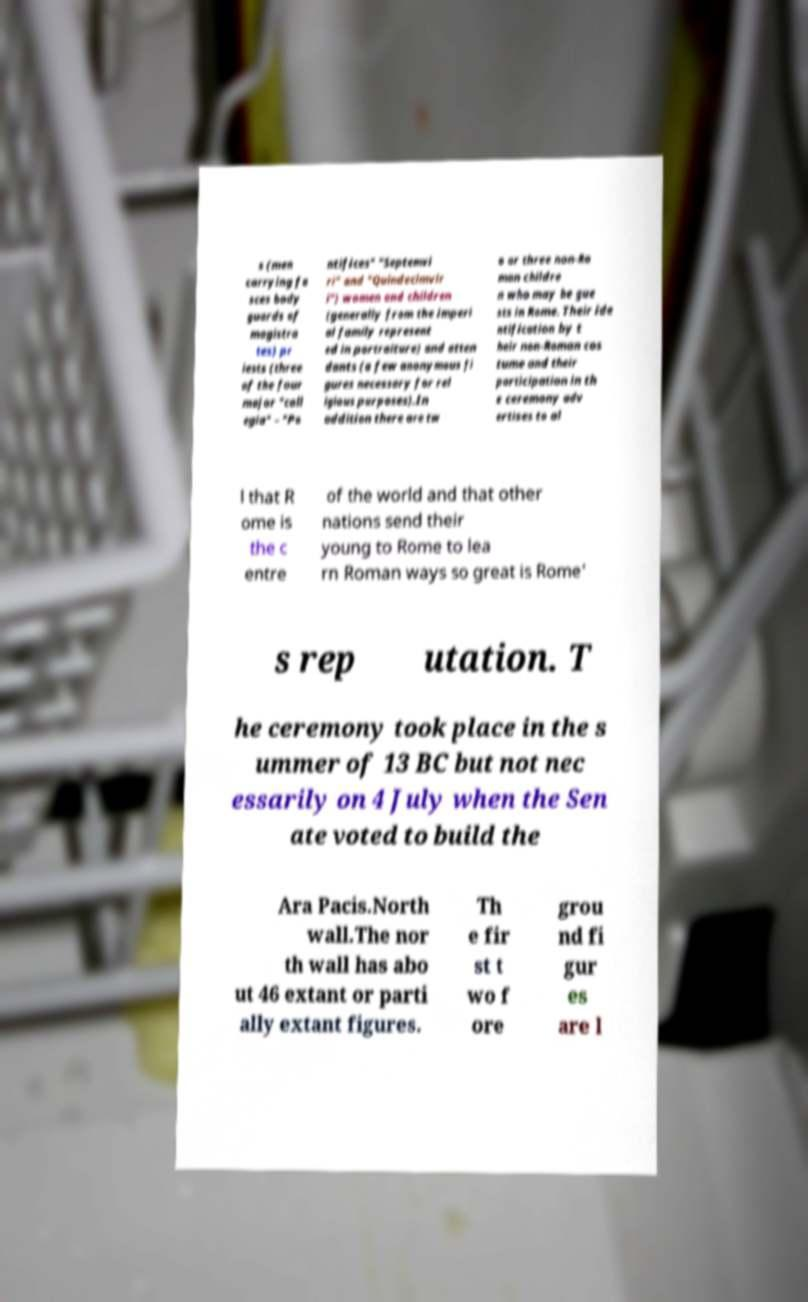Please identify and transcribe the text found in this image. s (men carrying fa sces body guards of magistra tes) pr iests (three of the four major "coll egia" – "Po ntifices" "Septemvi ri" and "Quindecimvir i") women and children (generally from the imperi al family represent ed in portraiture) and atten dants (a few anonymous fi gures necessary for rel igious purposes).In addition there are tw o or three non-Ro man childre n who may be gue sts in Rome. Their ide ntification by t heir non-Roman cos tume and their participation in th e ceremony adv ertises to al l that R ome is the c entre of the world and that other nations send their young to Rome to lea rn Roman ways so great is Rome' s rep utation. T he ceremony took place in the s ummer of 13 BC but not nec essarily on 4 July when the Sen ate voted to build the Ara Pacis.North wall.The nor th wall has abo ut 46 extant or parti ally extant figures. Th e fir st t wo f ore grou nd fi gur es are l 